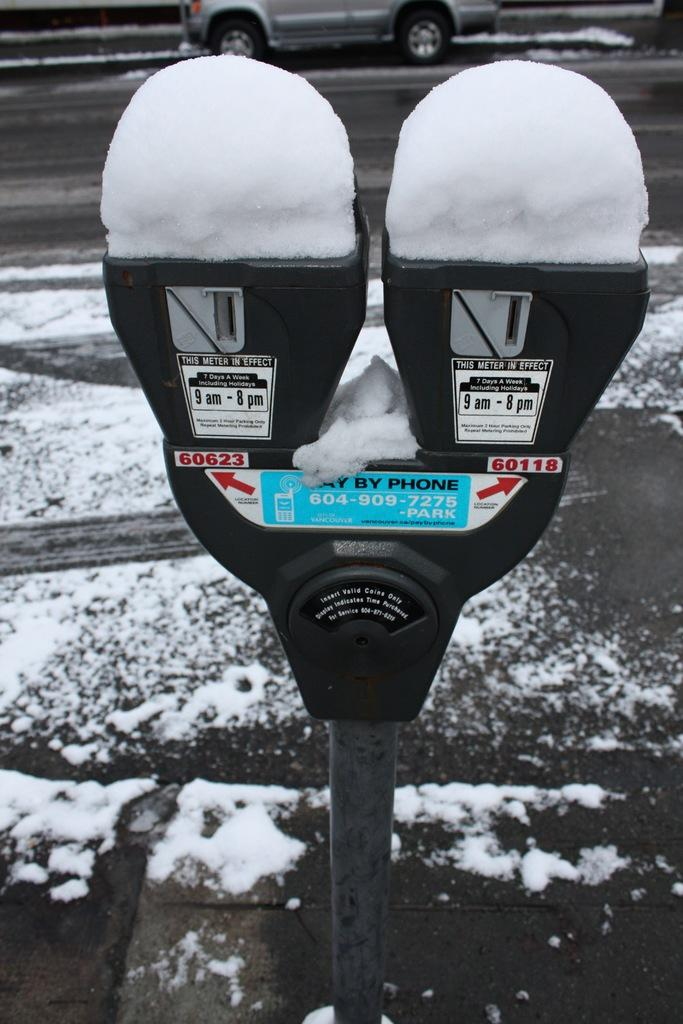Provide a one-sentence caption for the provided image. With these parking meters you can pay by phone. 